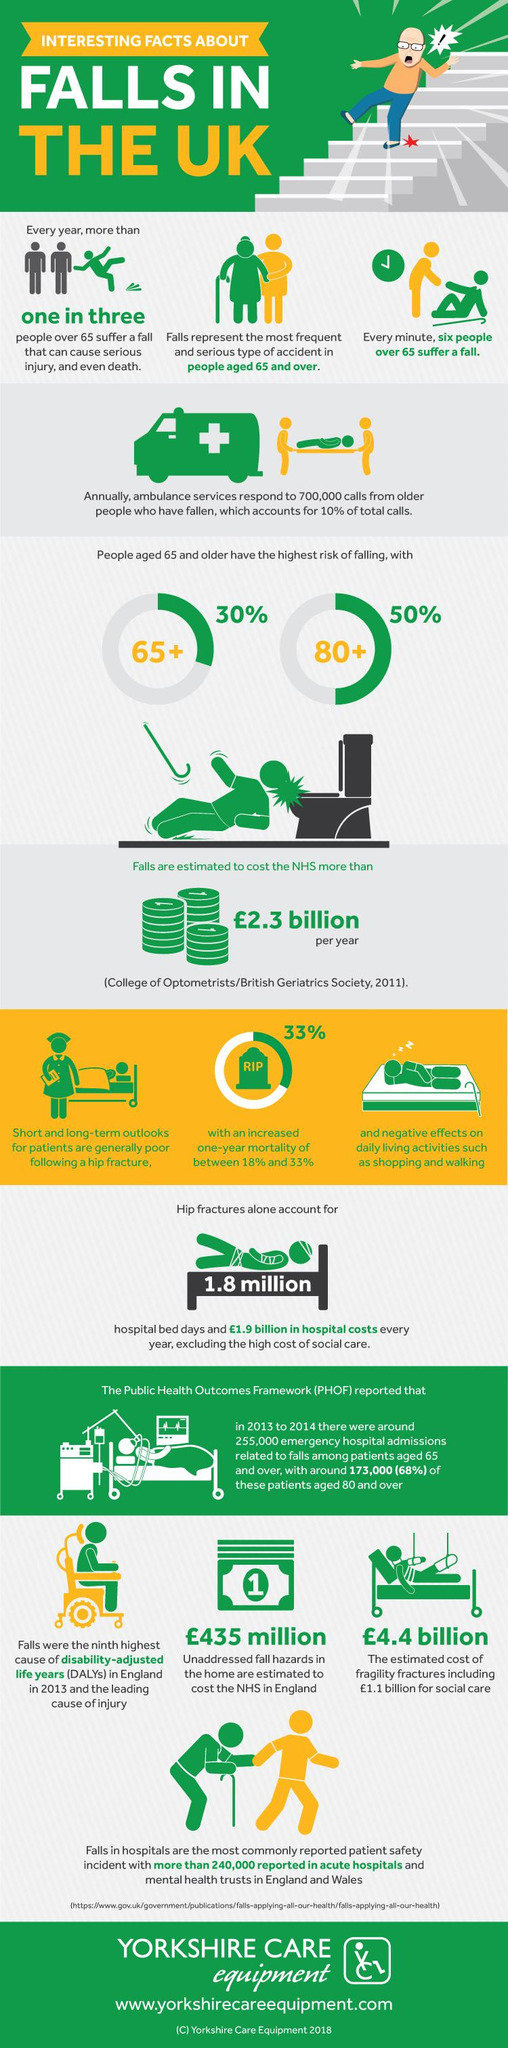Mention a couple of crucial points in this snapshot. It is estimated that there is a 50% chance that senior citizens above the age of 80 in the UK will fall in a year. There is a significant risk of senior citizens above the age of 65 in the UK falling in a given year, with the chance being approximately 70%. It is estimated that approximately 30% of senior citizens in the UK aged 65 and above are likely to fall in a year. According to data on ambulance services, only 10% of the calls received are related to falls. Approximately 5 million senior citizens in the UK do not fall every minute. 